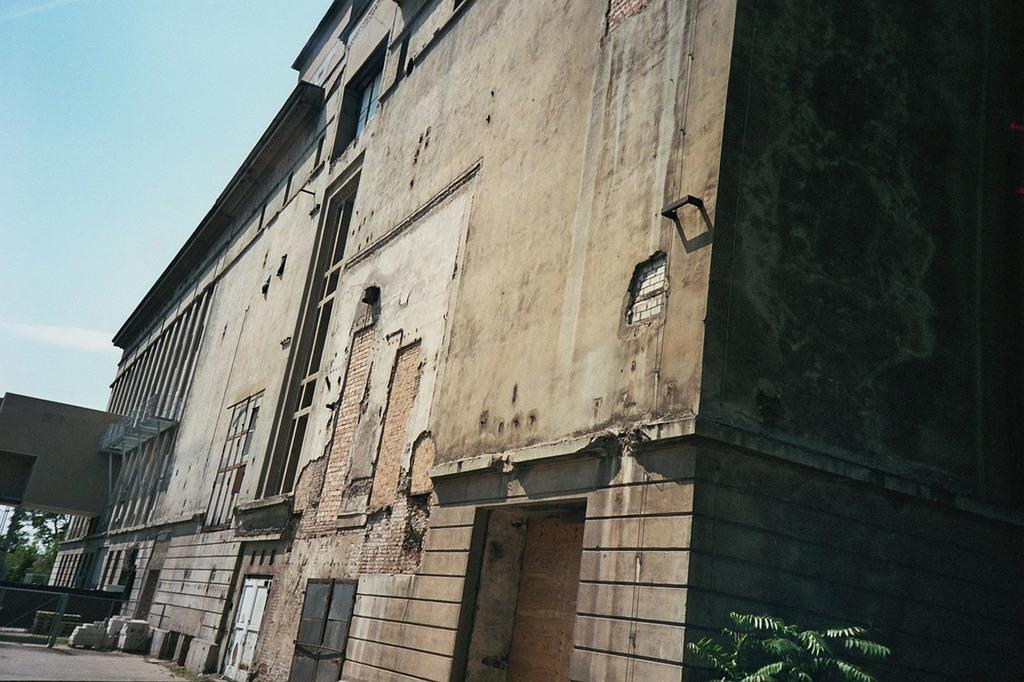What type of structure is present in the image? There is a building in the image. What features can be seen on the building? The building has windows and a door. What other elements are present in the image besides the building? There are plants, a fence, trees, and the sky visible in the image. How would you describe the sky in the image? The sky appears to be cloudy in the image. Can you tell me how many basketballs are visible in the image? There are no basketballs present in the image. Where is the best spot to sit and enjoy the view in the image? The image does not provide information about a specific spot to sit and enjoy the view. 